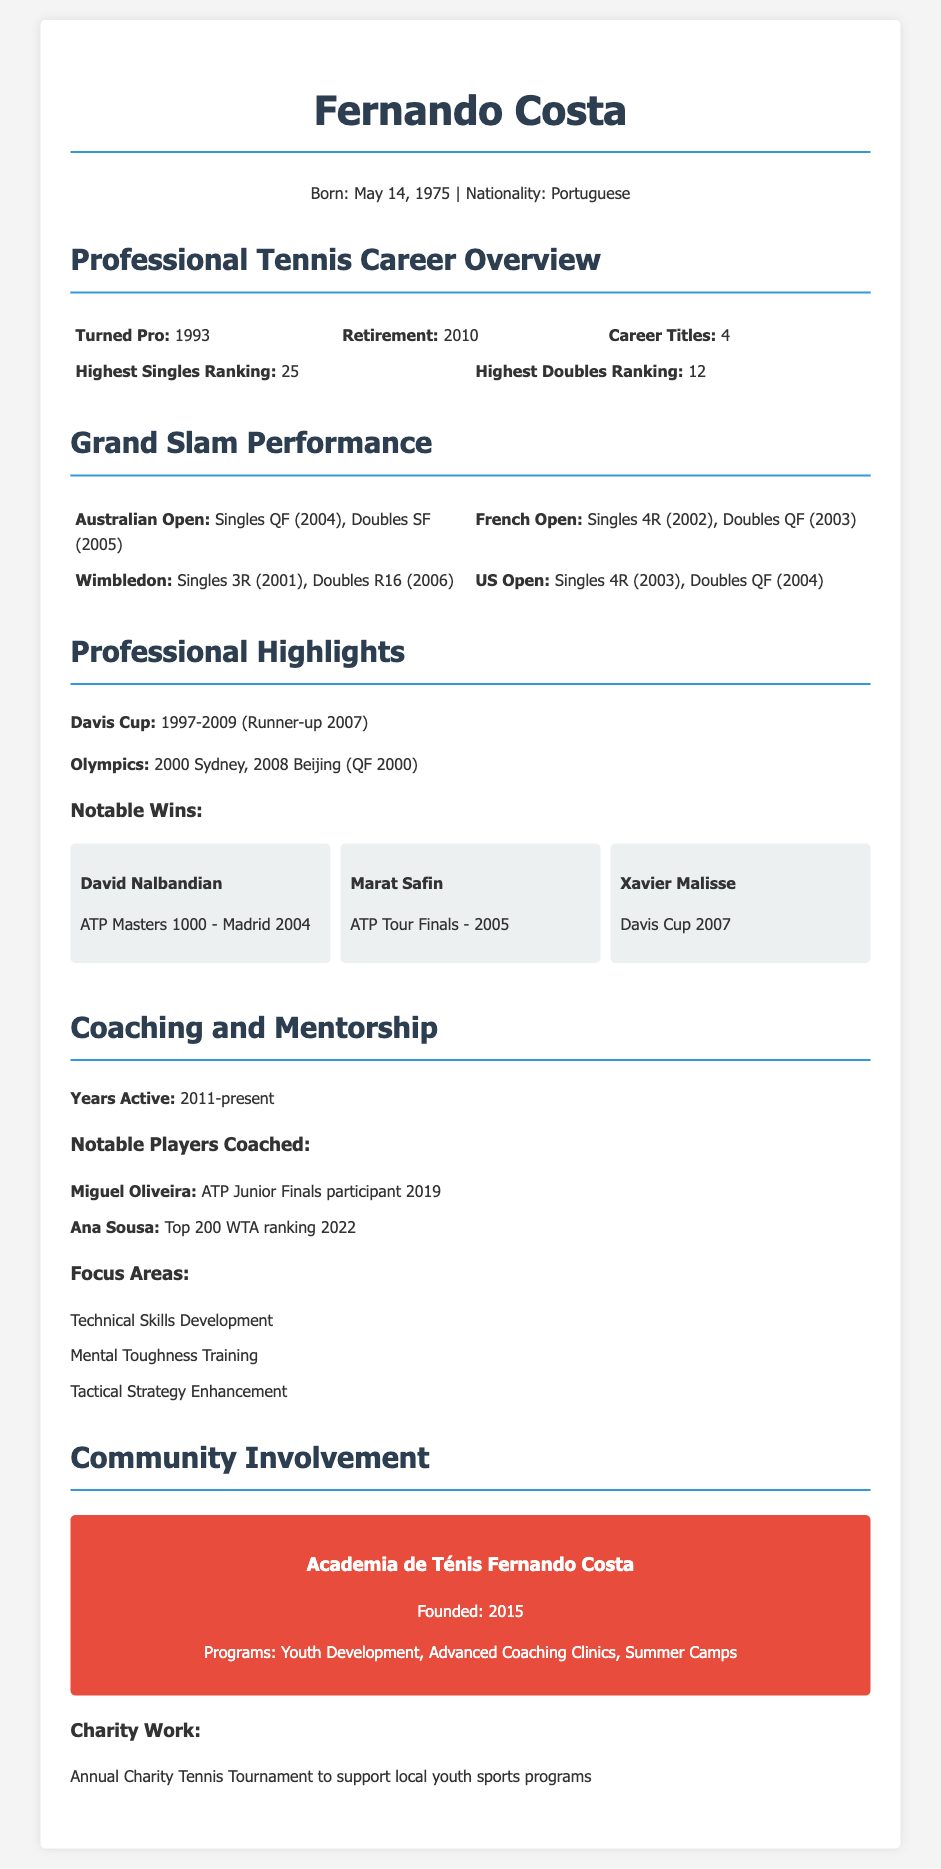What year did Fernando Costa turn pro? The document states that Fernando Costa turned pro in 1993.
Answer: 1993 What is Fernando Costa's highest singles ranking? According to the document, Fernando Costa's highest singles ranking is 25.
Answer: 25 How many career titles did Fernando Costa win? The document mentions that Fernando Costa won a total of 4 career titles.
Answer: 4 In which year did Fernando Costa retire? The document indicates that Fernando Costa retired in 2010.
Answer: 2010 What notable win did Fernando Costa achieve against David Nalbandian? The document specifies that he won against David Nalbandian at the ATP Masters 1000 in Madrid 2004.
Answer: ATP Masters 1000 - Madrid 2004 What focus areas are mentioned for coaching? The document lists Technical Skills Development, Mental Toughness Training, and Tactical Strategy Enhancement as focus areas.
Answer: Technical Skills Development, Mental Toughness Training, Tactical Strategy Enhancement What charity activity is associated with Fernando Costa? The document describes an annual charity tennis tournament to support local youth sports programs.
Answer: Annual Charity Tennis Tournament Which player coached by Fernando Costa achieved a top 200 WTA ranking? The document mentions Ana Sousa as a player coached by Fernando Costa who achieved a top 200 WTA ranking in 2022.
Answer: Ana Sousa What is the name of the academy founded by Fernando Costa? The document states that he founded "Academia de Ténis Fernando Costa."
Answer: Academia de Ténis Fernando Costa 